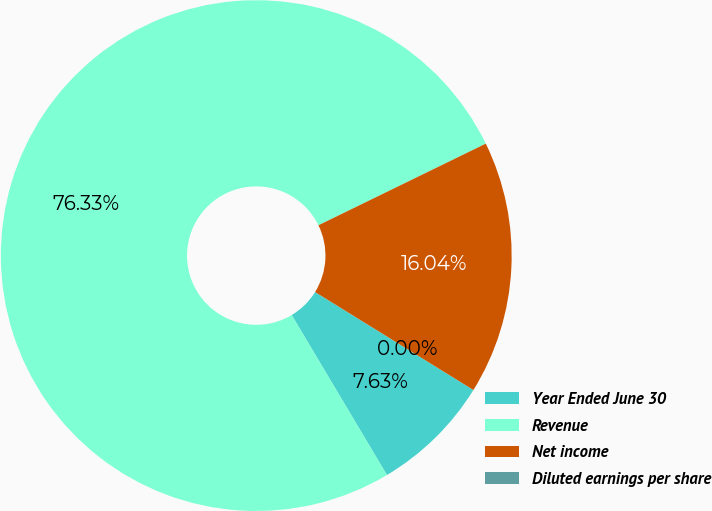Convert chart. <chart><loc_0><loc_0><loc_500><loc_500><pie_chart><fcel>Year Ended June 30<fcel>Revenue<fcel>Net income<fcel>Diluted earnings per share<nl><fcel>7.63%<fcel>76.32%<fcel>16.04%<fcel>0.0%<nl></chart> 